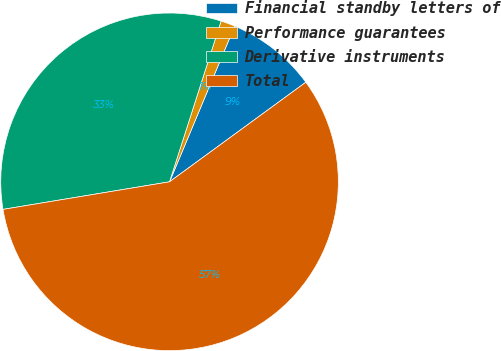<chart> <loc_0><loc_0><loc_500><loc_500><pie_chart><fcel>Financial standby letters of<fcel>Performance guarantees<fcel>Derivative instruments<fcel>Total<nl><fcel>8.65%<fcel>1.37%<fcel>32.55%<fcel>57.43%<nl></chart> 